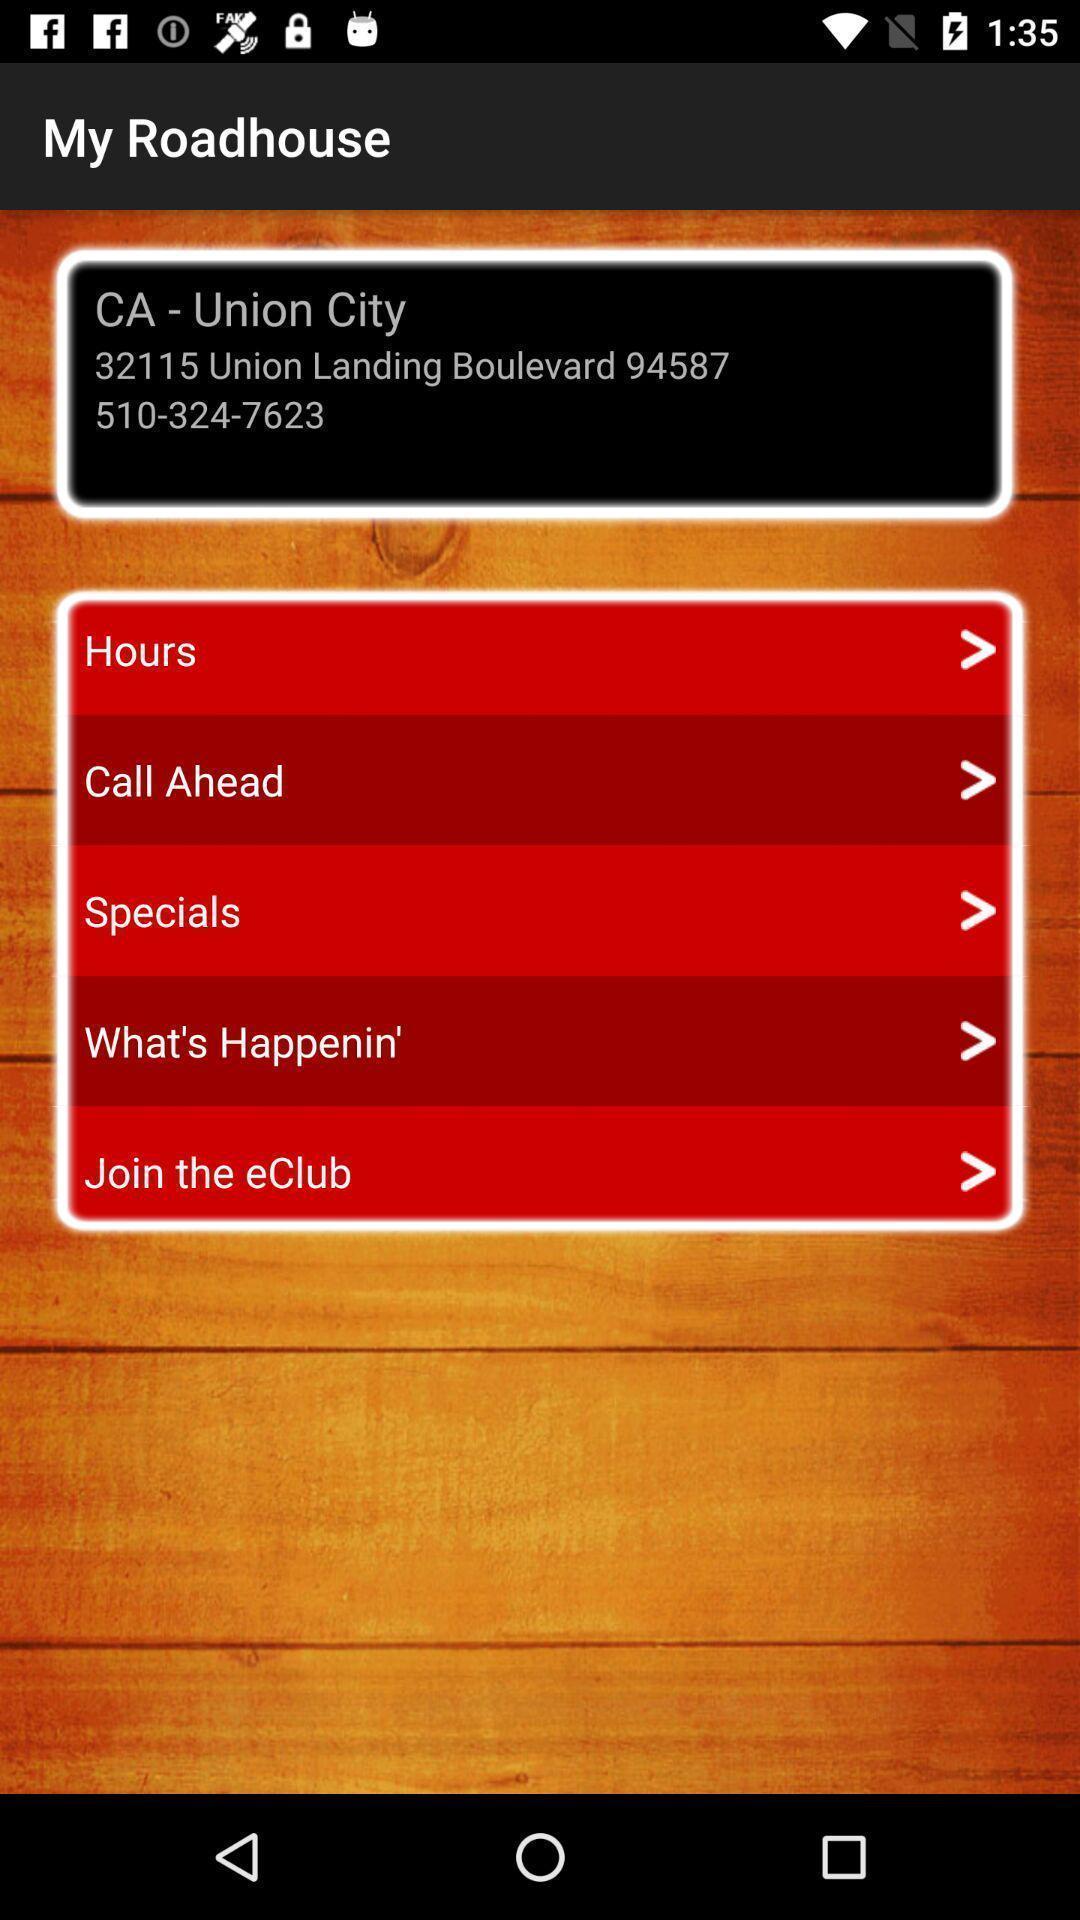Provide a textual representation of this image. Screen showing address of a location. 